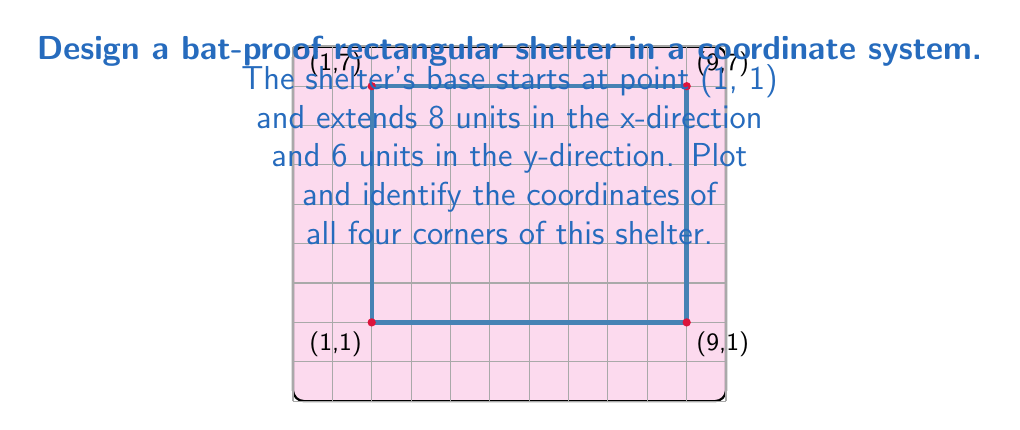Could you help me with this problem? To solve this problem, we need to follow these steps:

1) The base point is given as (1, 1). This is our starting point and the first corner of the rectangle.

2) The shelter extends 8 units in the x-direction. To find the second corner:
   $x = 1 + 8 = 9$
   $y$ remains 1
   So, the second corner is at (9, 1)

3) From the second corner, the shelter extends 6 units in the y-direction. To find the third corner:
   $x$ remains 9
   $y = 1 + 6 = 7$
   So, the third corner is at (9, 7)

4) For the fourth corner, we move back to the original x-coordinate but keep the new y-coordinate:
   $x = 1$
   $y = 7$
   So, the fourth corner is at (1, 7)

5) We can now list all four corners in order:
   $(1, 1)$, $(9, 1)$, $(9, 7)$, $(1, 7)$

These coordinates form a rectangle that is 8 units wide and 6 units tall, providing a secure shelter against bats.
Answer: $(1, 1)$, $(9, 1)$, $(9, 7)$, $(1, 7)$ 